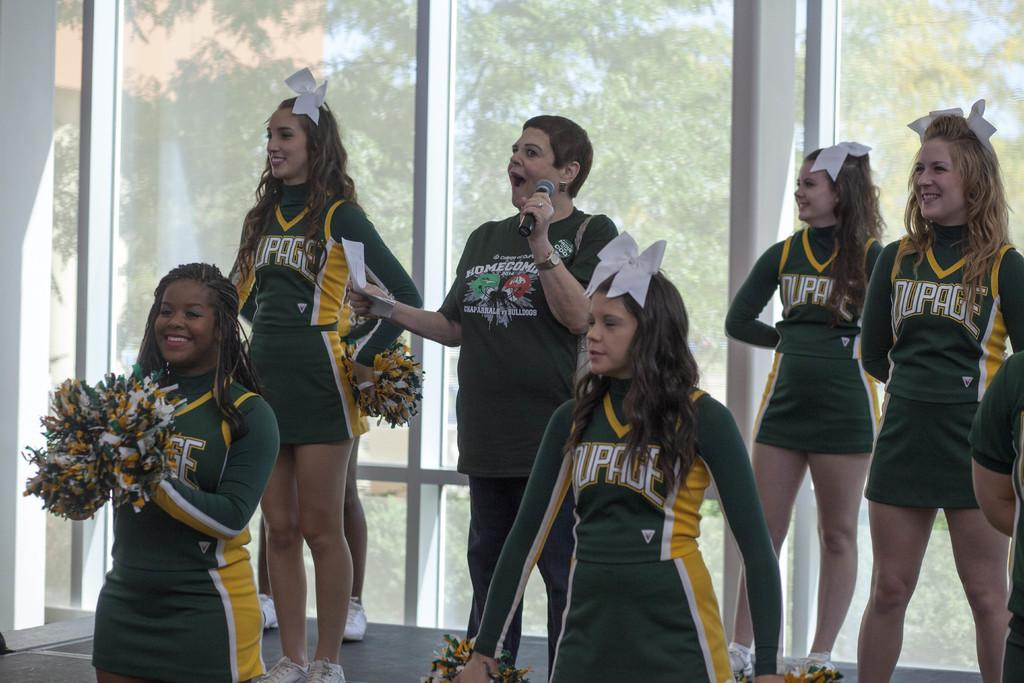<image>
Share a concise interpretation of the image provided. A woman wearing a Homecoming shirt is speaking into a microphone surrounded by cheerleaders. 